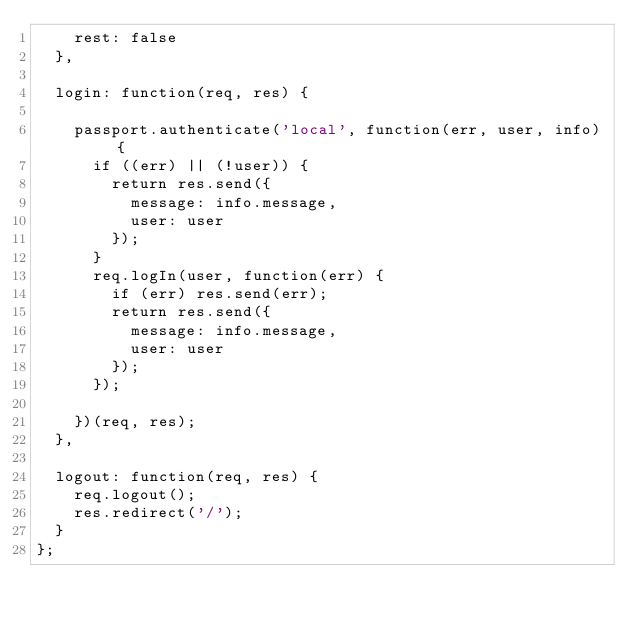Convert code to text. <code><loc_0><loc_0><loc_500><loc_500><_JavaScript_>    rest: false
  },

  login: function(req, res) {

    passport.authenticate('local', function(err, user, info) {
      if ((err) || (!user)) {
        return res.send({
          message: info.message,
          user: user
        });
      }
      req.logIn(user, function(err) {
        if (err) res.send(err);
        return res.send({
          message: info.message,
          user: user
        });
      });

    })(req, res);
  },

  logout: function(req, res) {
    req.logout();
    res.redirect('/');
  }
};
</code> 